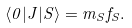Convert formula to latex. <formula><loc_0><loc_0><loc_500><loc_500>\langle 0 | J | S \rangle = m _ { S } f _ { S } .</formula> 